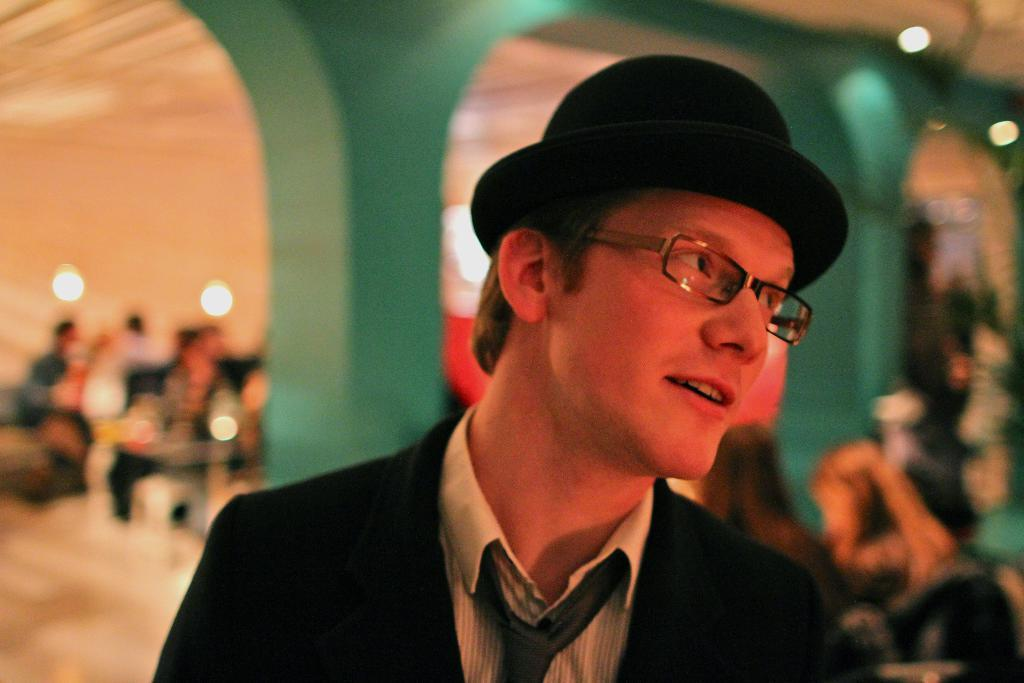What is the main subject in the middle of the image? There is a man in the middle of the image. What accessories is the man wearing? The man is wearing a hat and specs. What can be seen in the background of the image? There are arches and people sitting in the background of the image. How much money is the man holding in the image? There is no indication of the man holding money in the image. What type of death is depicted in the image? There is no depiction of death in the image; it features a man wearing a hat and specs, with arches and people sitting in the background. 